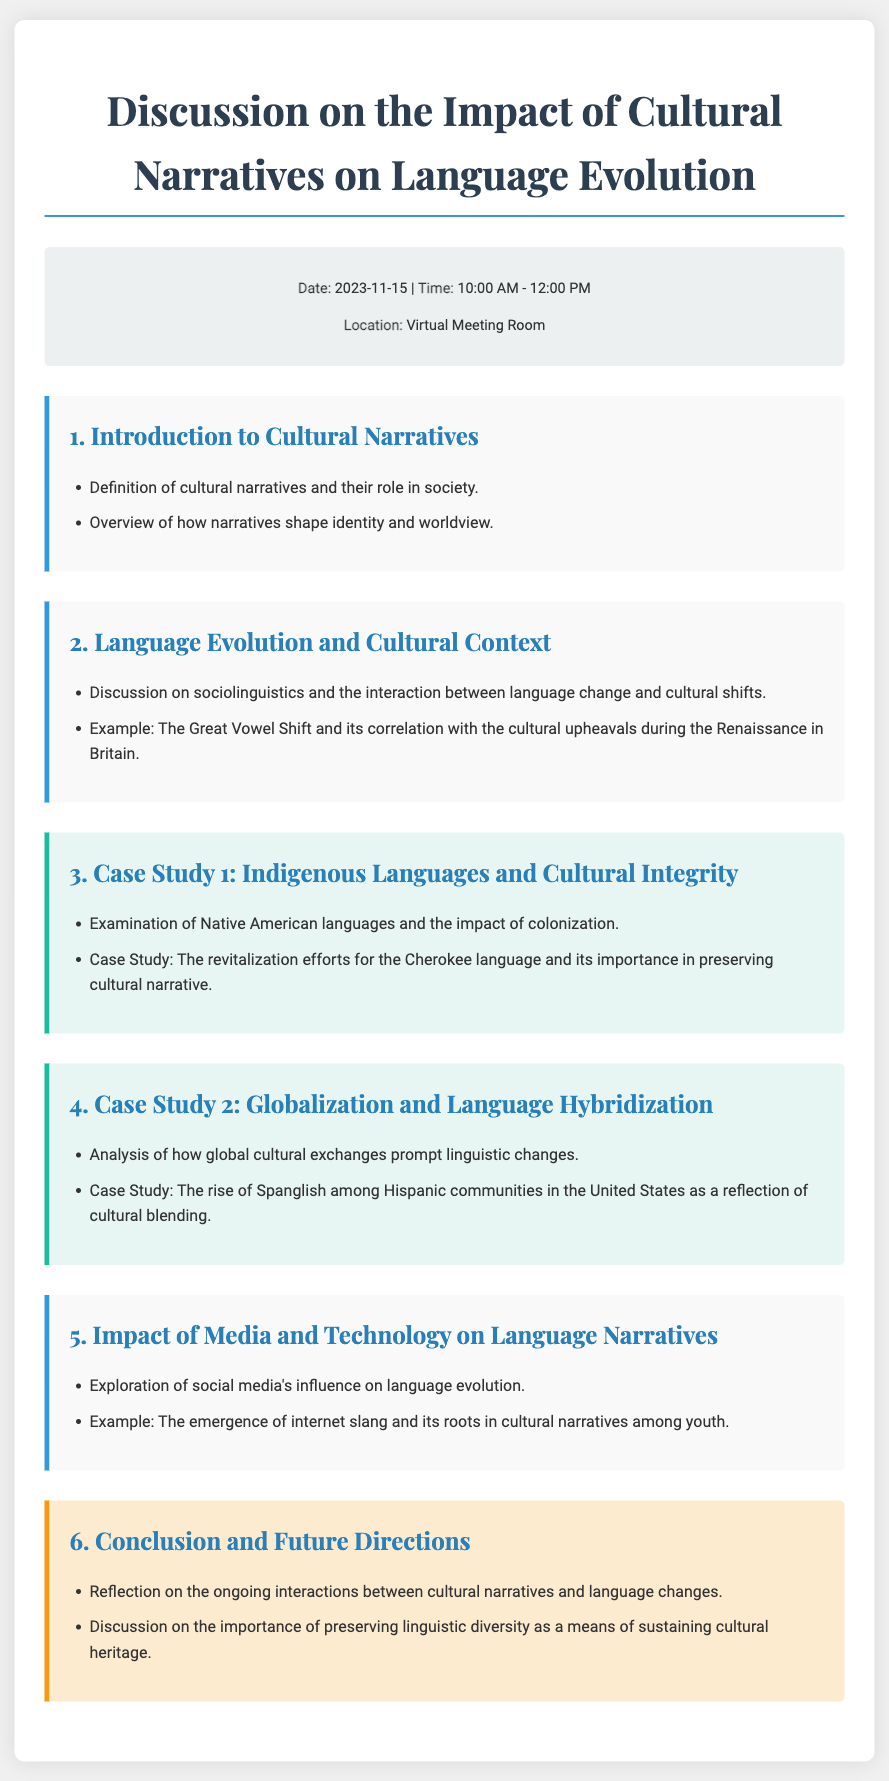What is the date of the discussion? The date of the discussion is specified in the meta-info section of the document.
Answer: 2023-11-15 What time does the discussion start? The time of the discussion is mentioned in the meta-info section.
Answer: 10:00 AM What is the first topic introduced in the agenda? The first topic is listed in the sections of the document.
Answer: Introduction to Cultural Narratives Which language is emphasized in Case Study 1? The language discussed in Case Study 1 is highlighted in the relevant section.
Answer: Cherokee What phenomenon is discussed in relation to the Great Vowel Shift? This phenomenon relates to cultural shifts during a historical period mentioned in the document.
Answer: Cultural upheavals during the Renaissance What is one impact of social media mentioned in the document? The impact discussed in the section on media and technology explains how language evolves.
Answer: Influence on language evolution How many case studies are included in the agenda? The number of case studies is counted based on the cases listed in the document.
Answer: Two What is a key conclusion highlighted in the final section? The conclusion emphasizes the importance of a specific aspect of language and culture as stated in the document.
Answer: Preserving linguistic diversity 